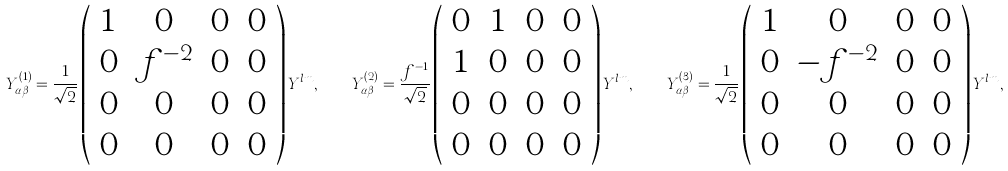<formula> <loc_0><loc_0><loc_500><loc_500>Y ^ { ( 1 ) } _ { \alpha \beta } = \frac { 1 } { \sqrt { 2 } } \left ( \begin{array} { c c c c } 1 & 0 & 0 & 0 \\ 0 & f ^ { - 2 } & 0 & 0 \\ 0 & 0 & 0 & 0 \\ 0 & 0 & 0 & 0 \end{array} \right ) Y ^ { l m } , \quad Y ^ { ( 2 ) } _ { \alpha \beta } = \frac { f ^ { - 1 } } { \sqrt { 2 } } \left ( \begin{array} { c c c c } 0 & 1 & 0 & 0 \\ 1 & 0 & 0 & 0 \\ 0 & 0 & 0 & 0 \\ 0 & 0 & 0 & 0 \end{array} \right ) Y ^ { l m } , \quad Y ^ { ( 3 ) } _ { \alpha \beta } = \frac { 1 } { \sqrt { 2 } } \left ( \begin{array} { c c c c } 1 & 0 & 0 & 0 \\ 0 & - f ^ { - 2 } & 0 & 0 \\ 0 & 0 & 0 & 0 \\ 0 & 0 & 0 & 0 \end{array} \right ) Y ^ { l m } ,</formula> 